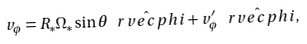<formula> <loc_0><loc_0><loc_500><loc_500>v _ { \phi } = R _ { * } \Omega _ { * } \sin \theta \hat { \ r v e c p h i } + v _ { \phi } ^ { \prime } \hat { \ r v e c p h i } ,</formula> 